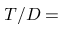<formula> <loc_0><loc_0><loc_500><loc_500>T / D =</formula> 